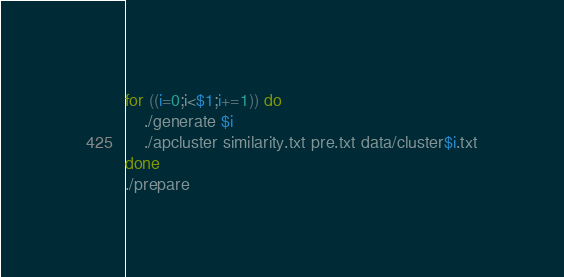Convert code to text. <code><loc_0><loc_0><loc_500><loc_500><_Bash_>for ((i=0;i<$1;i+=1)) do
	./generate $i
	./apcluster similarity.txt pre.txt data/cluster$i.txt
done
./prepare
</code> 